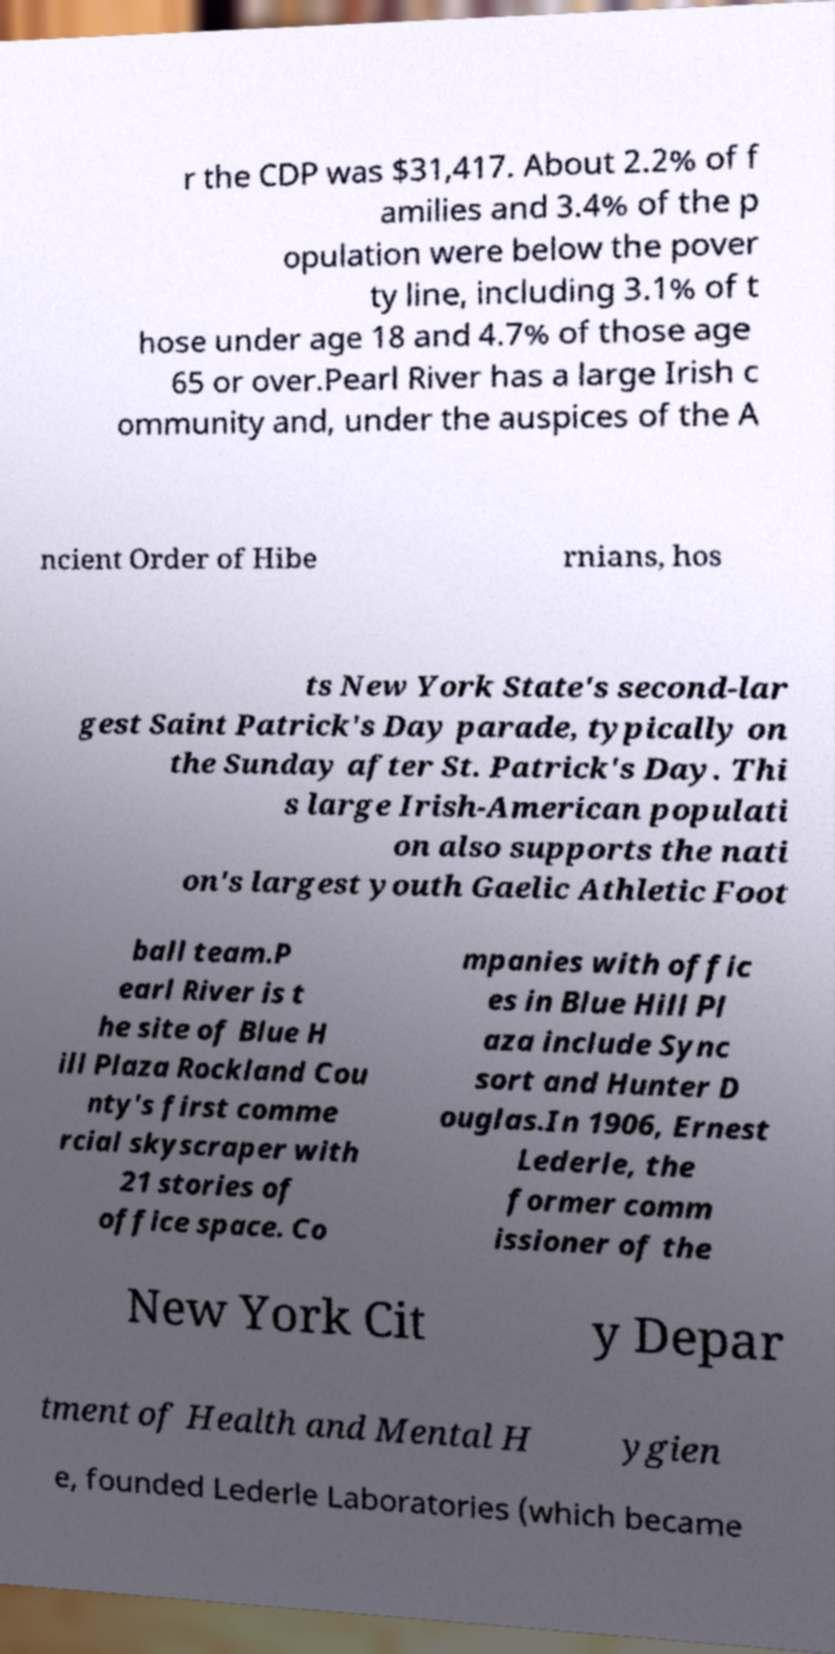For documentation purposes, I need the text within this image transcribed. Could you provide that? r the CDP was $31,417. About 2.2% of f amilies and 3.4% of the p opulation were below the pover ty line, including 3.1% of t hose under age 18 and 4.7% of those age 65 or over.Pearl River has a large Irish c ommunity and, under the auspices of the A ncient Order of Hibe rnians, hos ts New York State's second-lar gest Saint Patrick's Day parade, typically on the Sunday after St. Patrick's Day. Thi s large Irish-American populati on also supports the nati on's largest youth Gaelic Athletic Foot ball team.P earl River is t he site of Blue H ill Plaza Rockland Cou nty's first comme rcial skyscraper with 21 stories of office space. Co mpanies with offic es in Blue Hill Pl aza include Sync sort and Hunter D ouglas.In 1906, Ernest Lederle, the former comm issioner of the New York Cit y Depar tment of Health and Mental H ygien e, founded Lederle Laboratories (which became 